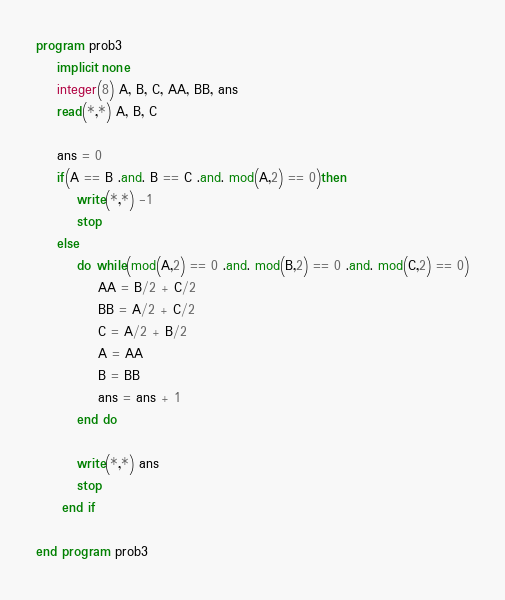Convert code to text. <code><loc_0><loc_0><loc_500><loc_500><_FORTRAN_>program prob3
    implicit none
    integer(8) A, B, C, AA, BB, ans
    read(*,*) A, B, C

    ans = 0
    if(A == B .and. B == C .and. mod(A,2) == 0)then
        write(*,*) -1
        stop
    else
        do while(mod(A,2) == 0 .and. mod(B,2) == 0 .and. mod(C,2) == 0)
            AA = B/2 + C/2
            BB = A/2 + C/2
            C = A/2 + B/2
            A = AA
            B = BB
            ans = ans + 1
        end do

        write(*,*) ans
        stop
     end if

end program prob3</code> 